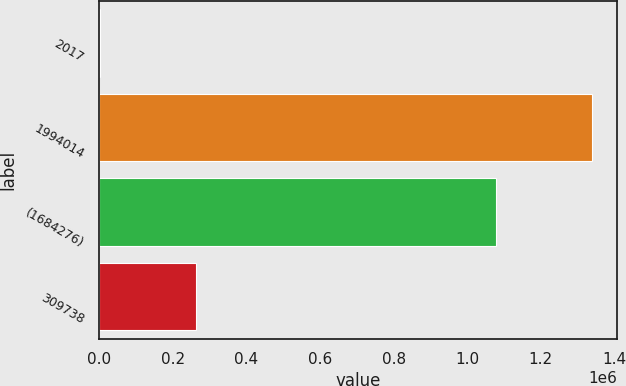Convert chart. <chart><loc_0><loc_0><loc_500><loc_500><bar_chart><fcel>2017<fcel>1994014<fcel>(1684276)<fcel>309738<nl><fcel>2016<fcel>1.34066e+06<fcel>1.07847e+06<fcel>262192<nl></chart> 